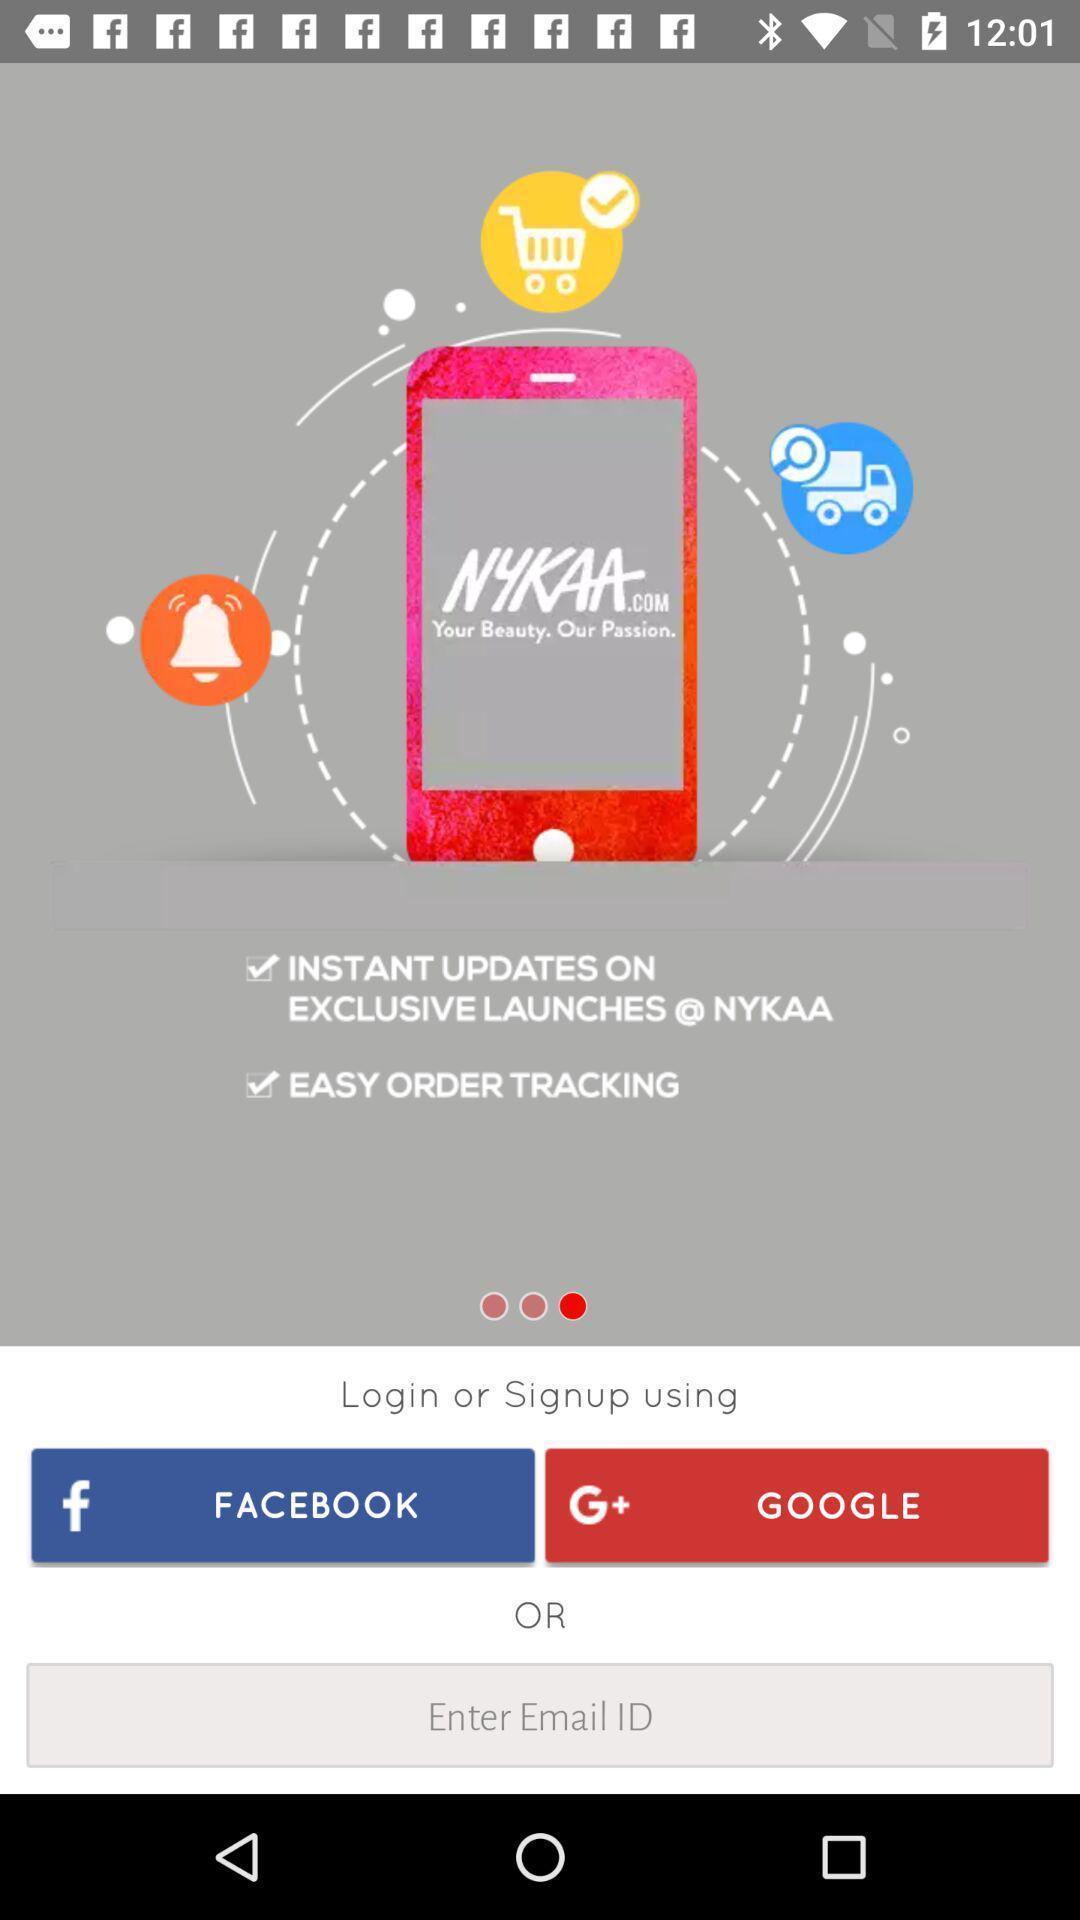Tell me what you see in this picture. Screen displaying multiple sign up options of a shoppimg application. 